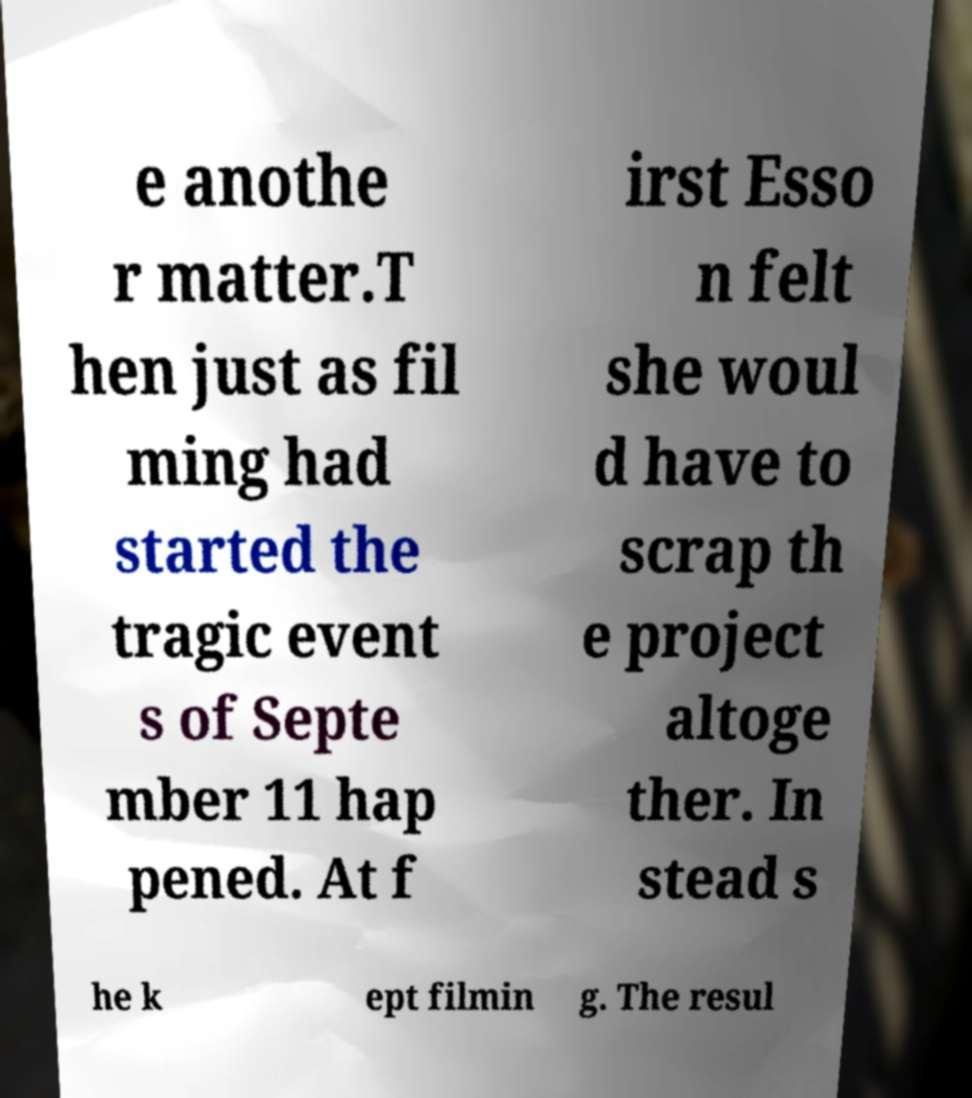Please read and relay the text visible in this image. What does it say? e anothe r matter.T hen just as fil ming had started the tragic event s of Septe mber 11 hap pened. At f irst Esso n felt she woul d have to scrap th e project altoge ther. In stead s he k ept filmin g. The resul 